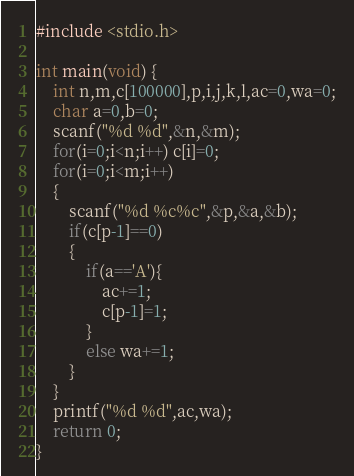Convert code to text. <code><loc_0><loc_0><loc_500><loc_500><_C_>#include <stdio.h>

int main(void) {
    int n,m,c[100000],p,i,j,k,l,ac=0,wa=0;
    char a=0,b=0;
    scanf("%d %d",&n,&m);
    for(i=0;i<n;i++) c[i]=0;
    for(i=0;i<m;i++)
    {
        scanf("%d %c%c",&p,&a,&b);
        if(c[p-1]==0)
        {
            if(a=='A'){
                ac+=1;
                c[p-1]=1;
            }
            else wa+=1;
        }
    }
    printf("%d %d",ac,wa);
    return 0;
}

</code> 